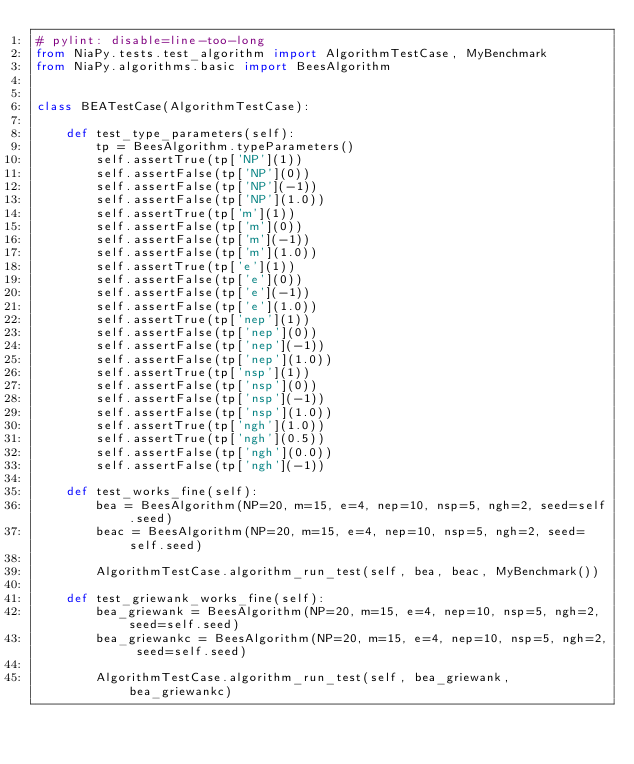Convert code to text. <code><loc_0><loc_0><loc_500><loc_500><_Python_># pylint: disable=line-too-long
from NiaPy.tests.test_algorithm import AlgorithmTestCase, MyBenchmark
from NiaPy.algorithms.basic import BeesAlgorithm


class BEATestCase(AlgorithmTestCase):

    def test_type_parameters(self):
        tp = BeesAlgorithm.typeParameters()
        self.assertTrue(tp['NP'](1))
        self.assertFalse(tp['NP'](0))
        self.assertFalse(tp['NP'](-1))
        self.assertFalse(tp['NP'](1.0))
        self.assertTrue(tp['m'](1))
        self.assertFalse(tp['m'](0))
        self.assertFalse(tp['m'](-1))
        self.assertFalse(tp['m'](1.0))
        self.assertTrue(tp['e'](1))
        self.assertFalse(tp['e'](0))
        self.assertFalse(tp['e'](-1))
        self.assertFalse(tp['e'](1.0))
        self.assertTrue(tp['nep'](1))
        self.assertFalse(tp['nep'](0))
        self.assertFalse(tp['nep'](-1))
        self.assertFalse(tp['nep'](1.0))
        self.assertTrue(tp['nsp'](1))
        self.assertFalse(tp['nsp'](0))
        self.assertFalse(tp['nsp'](-1))
        self.assertFalse(tp['nsp'](1.0))
        self.assertTrue(tp['ngh'](1.0))
        self.assertTrue(tp['ngh'](0.5))
        self.assertFalse(tp['ngh'](0.0))
        self.assertFalse(tp['ngh'](-1))

    def test_works_fine(self):
        bea = BeesAlgorithm(NP=20, m=15, e=4, nep=10, nsp=5, ngh=2, seed=self.seed)
        beac = BeesAlgorithm(NP=20, m=15, e=4, nep=10, nsp=5, ngh=2, seed=self.seed)

        AlgorithmTestCase.algorithm_run_test(self, bea, beac, MyBenchmark())

    def test_griewank_works_fine(self):
        bea_griewank = BeesAlgorithm(NP=20, m=15, e=4, nep=10, nsp=5, ngh=2, seed=self.seed)
        bea_griewankc = BeesAlgorithm(NP=20, m=15, e=4, nep=10, nsp=5, ngh=2, seed=self.seed)

        AlgorithmTestCase.algorithm_run_test(self, bea_griewank, bea_griewankc)
</code> 